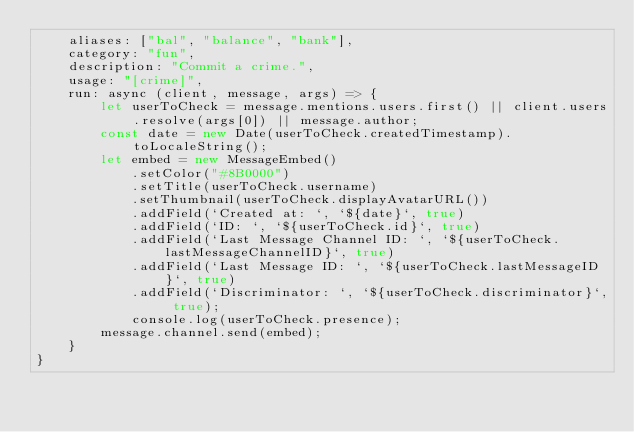<code> <loc_0><loc_0><loc_500><loc_500><_JavaScript_>    aliases: ["bal", "balance", "bank"],
    category: "fun",
    description: "Commit a crime.",
    usage: "[crime]",
    run: async (client, message, args) => {
        let userToCheck = message.mentions.users.first() || client.users.resolve(args[0]) || message.author;
        const date = new Date(userToCheck.createdTimestamp).toLocaleString();
        let embed = new MessageEmbed()
            .setColor("#8B0000")
            .setTitle(userToCheck.username)
            .setThumbnail(userToCheck.displayAvatarURL())
            .addField(`Created at: `, `${date}`, true)
            .addField(`ID: `, `${userToCheck.id}`, true)
            .addField(`Last Message Channel ID: `, `${userToCheck.lastMessageChannelID}`, true)
            .addField(`Last Message ID: `, `${userToCheck.lastMessageID}`, true)
            .addField(`Discriminator: `, `${userToCheck.discriminator}`, true);
            console.log(userToCheck.presence);
        message.channel.send(embed);
    }
}</code> 